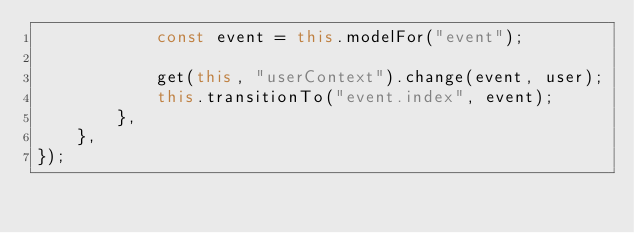<code> <loc_0><loc_0><loc_500><loc_500><_JavaScript_>            const event = this.modelFor("event");

            get(this, "userContext").change(event, user);
            this.transitionTo("event.index", event);
        },
    },
});
</code> 